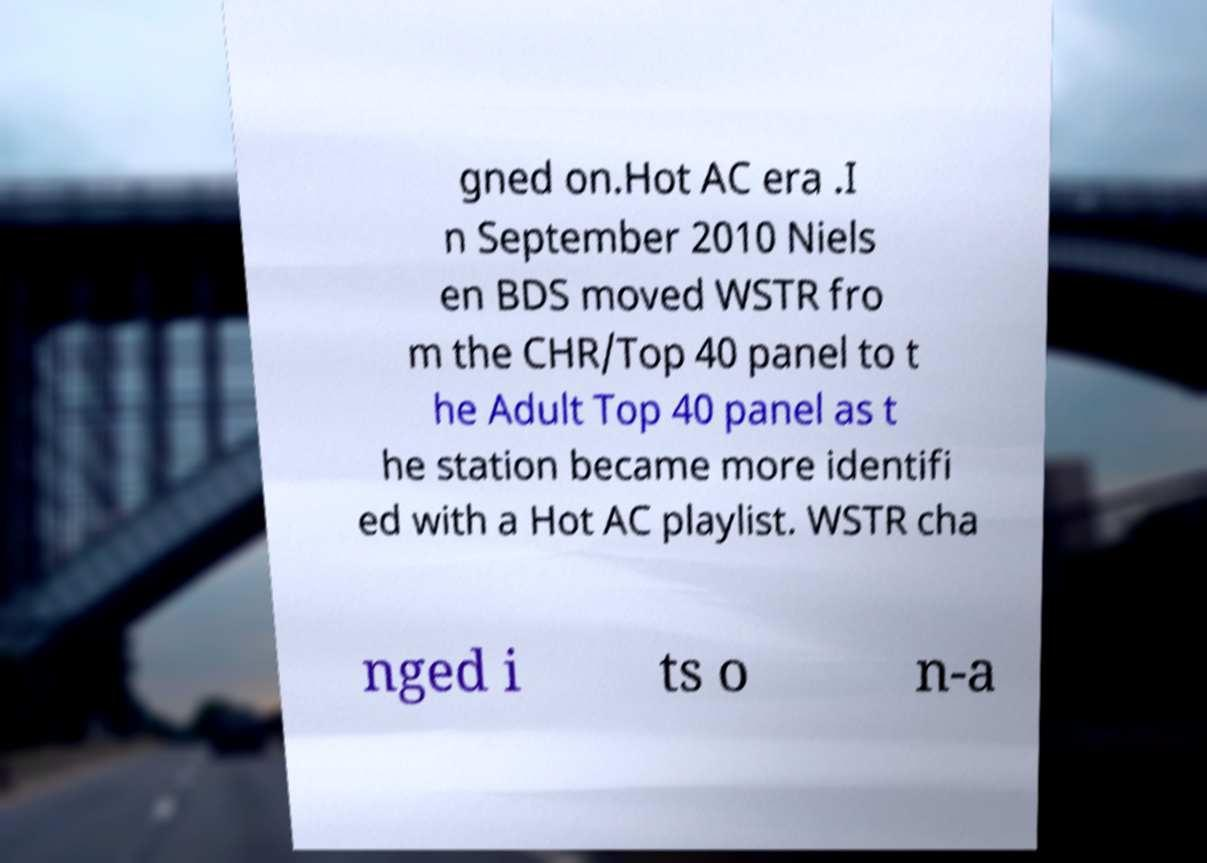Can you accurately transcribe the text from the provided image for me? gned on.Hot AC era .I n September 2010 Niels en BDS moved WSTR fro m the CHR/Top 40 panel to t he Adult Top 40 panel as t he station became more identifi ed with a Hot AC playlist. WSTR cha nged i ts o n-a 